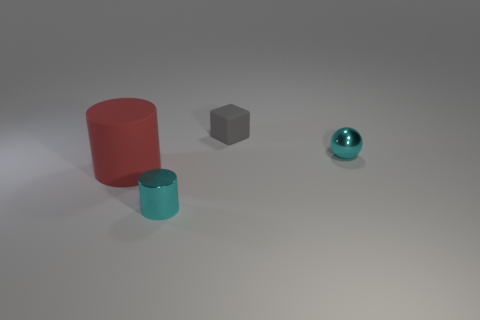Are there any other things that have the same size as the red matte cylinder?
Make the answer very short. No. There is a shiny thing that is the same color as the metal cylinder; what is its shape?
Provide a short and direct response. Sphere. Are there any other things that have the same color as the small ball?
Keep it short and to the point. Yes. There is a sphere; is its color the same as the cylinder to the right of the large red rubber thing?
Provide a succinct answer. Yes. There is a cyan metal thing that is to the right of the cyan cylinder; is its size the same as the rubber object left of the gray block?
Offer a terse response. No. What number of large red things are the same material as the ball?
Make the answer very short. 0. What color is the tiny cylinder?
Ensure brevity in your answer.  Cyan. Are there any cyan cylinders in front of the big red thing?
Offer a very short reply. Yes. Does the small cylinder have the same color as the small ball?
Offer a terse response. Yes. How many small matte things are the same color as the cube?
Offer a very short reply. 0. 